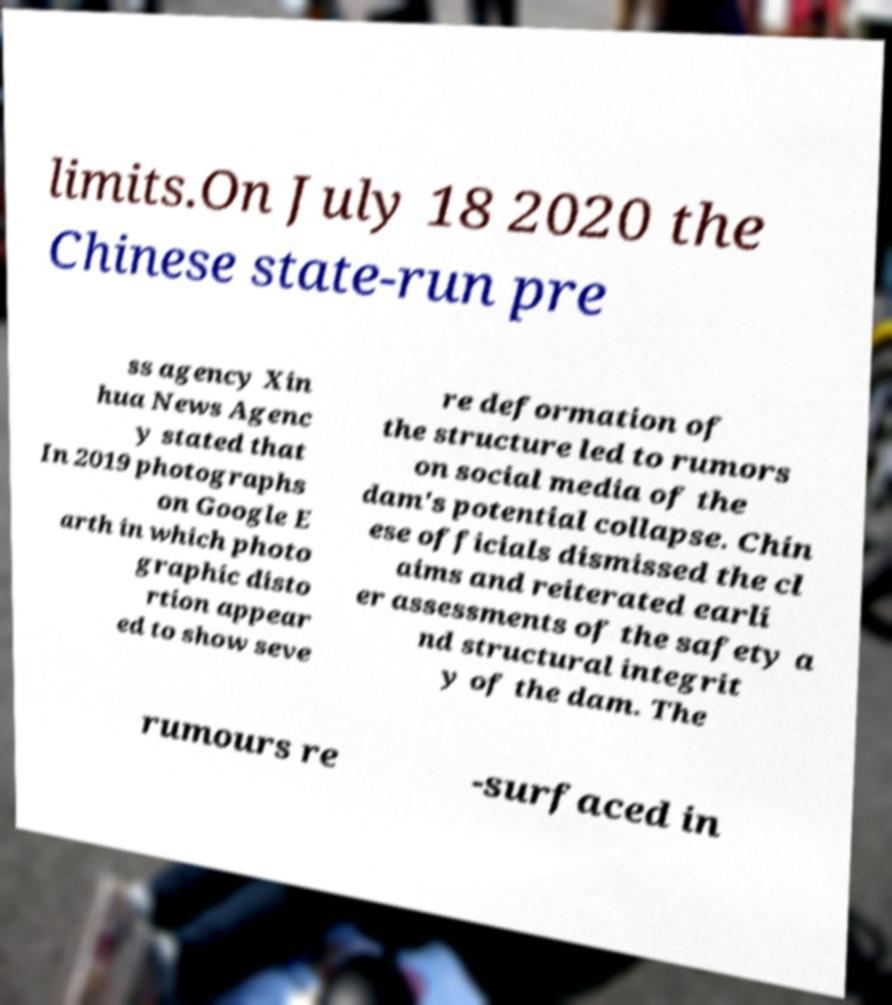For documentation purposes, I need the text within this image transcribed. Could you provide that? limits.On July 18 2020 the Chinese state-run pre ss agency Xin hua News Agenc y stated that In 2019 photographs on Google E arth in which photo graphic disto rtion appear ed to show seve re deformation of the structure led to rumors on social media of the dam's potential collapse. Chin ese officials dismissed the cl aims and reiterated earli er assessments of the safety a nd structural integrit y of the dam. The rumours re -surfaced in 